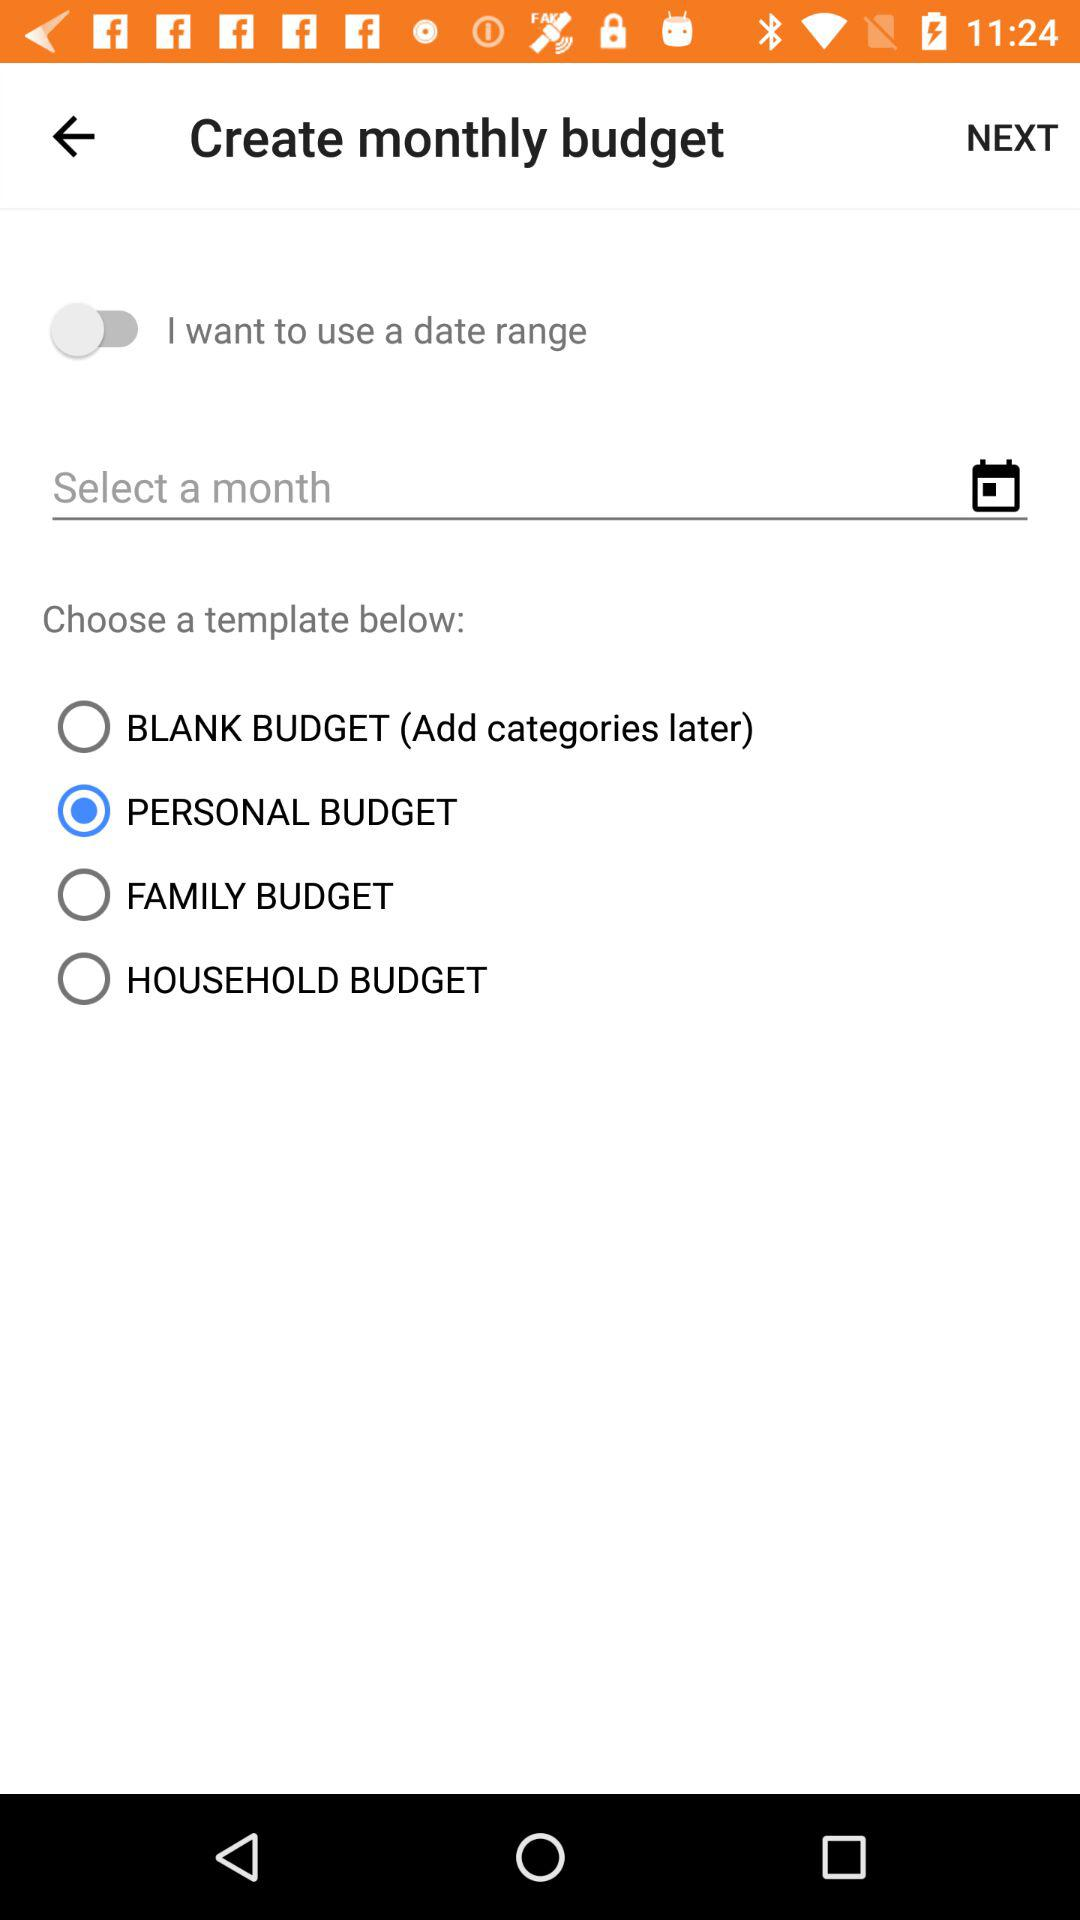How many templates are available for the monthly budget?
Answer the question using a single word or phrase. 4 